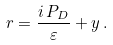<formula> <loc_0><loc_0><loc_500><loc_500>r = \frac { i \, P _ { D } } { \varepsilon } + y \, .</formula> 